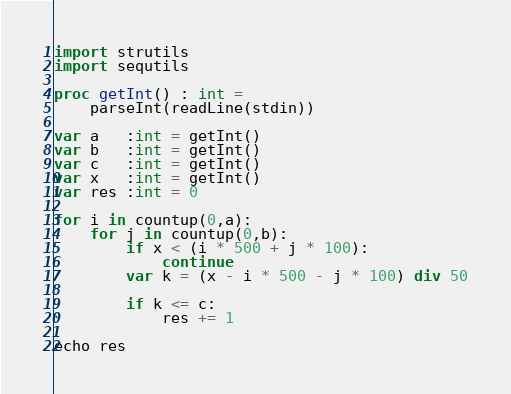Convert code to text. <code><loc_0><loc_0><loc_500><loc_500><_Nim_>import strutils
import sequtils

proc getInt() : int =
    parseInt(readLine(stdin))

var a   :int = getInt()
var b   :int = getInt()
var c   :int = getInt()
var x   :int = getInt()
var res :int = 0

for i in countup(0,a):
    for j in countup(0,b):
        if x < (i * 500 + j * 100):
            continue
        var k = (x - i * 500 - j * 100) div 50

        if k <= c:
            res += 1

echo res</code> 